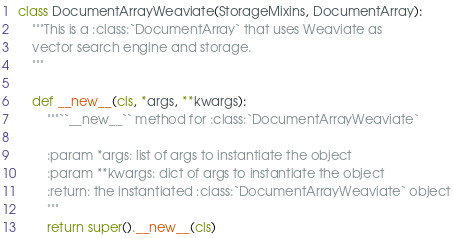<code> <loc_0><loc_0><loc_500><loc_500><_Python_>

class DocumentArrayWeaviate(StorageMixins, DocumentArray):
    """This is a :class:`DocumentArray` that uses Weaviate as
    vector search engine and storage.
    """

    def __new__(cls, *args, **kwargs):
        """``__new__`` method for :class:`DocumentArrayWeaviate`

        :param *args: list of args to instantiate the object
        :param **kwargs: dict of args to instantiate the object
        :return: the instantiated :class:`DocumentArrayWeaviate` object
        """
        return super().__new__(cls)
</code> 